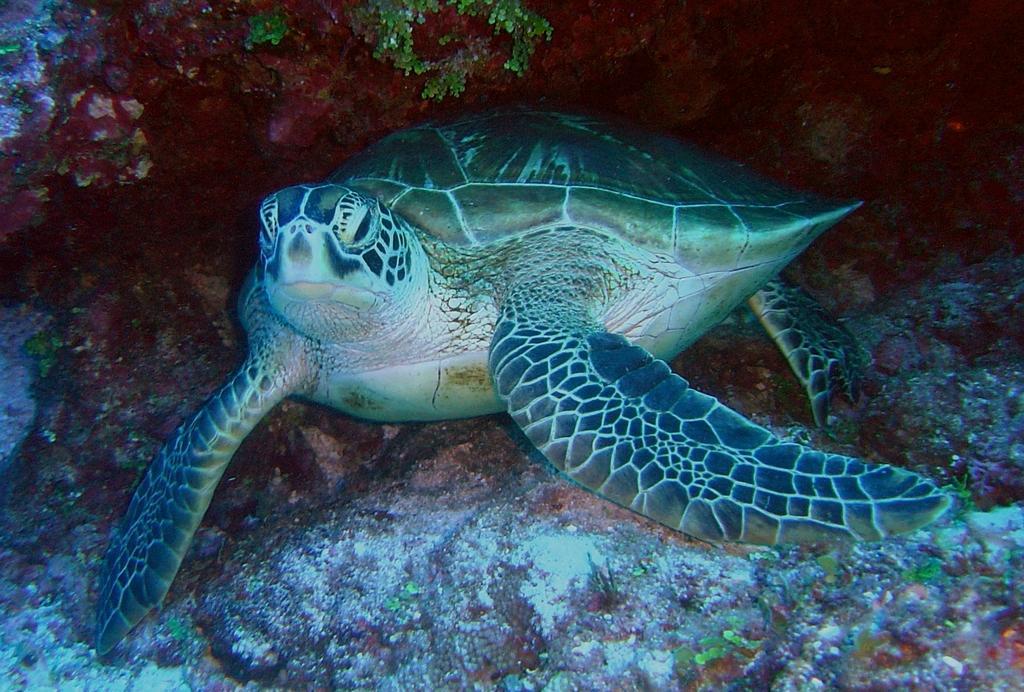How would you summarize this image in a sentence or two? In this image I can see a turtle in the centre and on the top of this image I can see grass. 